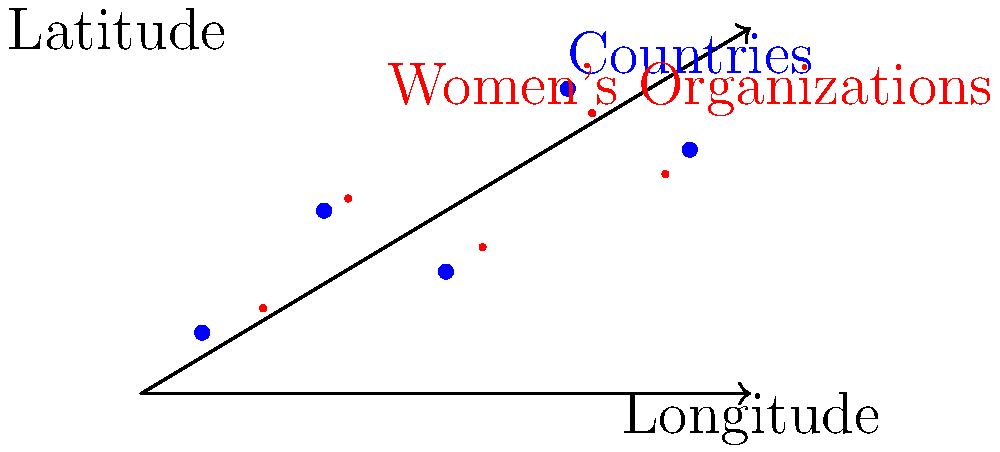In the vector-based world map above, blue dots represent countries, and red dots represent influential women's organizations. If we want to analyze the geographical spread of these organizations, which vector operation would be most useful for calculating the average location of all the organizations? To find the average location of all the women's organizations, we need to follow these steps:

1. Recognize that each organization's location is represented by a vector with two components: longitude (x-coordinate) and latitude (y-coordinate).

2. To find the average location, we need to calculate the centroid of all the organization vectors. This involves:
   a. Adding up all the vectors
   b. Dividing the result by the total number of vectors

3. In vector notation, this can be expressed as:

   $$\vec{C} = \frac{1}{n} \sum_{i=1}^n \vec{v_i}$$

   Where $\vec{C}$ is the centroid vector, $n$ is the number of organizations, and $\vec{v_i}$ are the individual organization vectors.

4. This operation is known as vector addition followed by scalar division.

5. The resulting vector $\vec{C}$ will give us the average longitude and latitude of all the organizations, representing their geographical center.

Therefore, the most useful vector operation for this analysis is vector addition (to sum up all location vectors) combined with scalar division (to find the average).
Answer: Vector addition and scalar division 